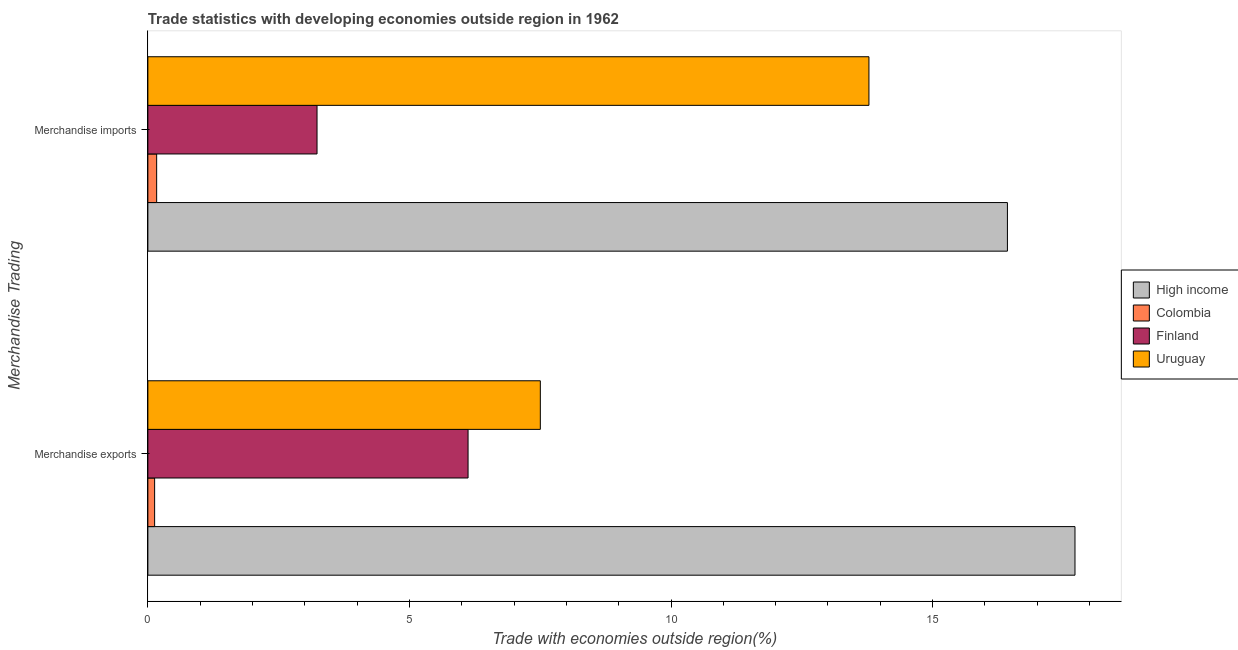How many different coloured bars are there?
Provide a short and direct response. 4. How many groups of bars are there?
Keep it short and to the point. 2. Are the number of bars on each tick of the Y-axis equal?
Make the answer very short. Yes. How many bars are there on the 1st tick from the top?
Give a very brief answer. 4. What is the merchandise imports in Uruguay?
Provide a succinct answer. 13.78. Across all countries, what is the maximum merchandise imports?
Make the answer very short. 16.43. Across all countries, what is the minimum merchandise exports?
Your answer should be compact. 0.13. In which country was the merchandise imports maximum?
Your answer should be compact. High income. What is the total merchandise exports in the graph?
Give a very brief answer. 31.47. What is the difference between the merchandise imports in Colombia and that in High income?
Your answer should be compact. -16.26. What is the difference between the merchandise imports in Colombia and the merchandise exports in High income?
Ensure brevity in your answer.  -17.55. What is the average merchandise imports per country?
Offer a very short reply. 8.4. What is the difference between the merchandise exports and merchandise imports in High income?
Ensure brevity in your answer.  1.29. What is the ratio of the merchandise imports in Finland to that in Uruguay?
Your response must be concise. 0.23. Is the merchandise imports in Finland less than that in Colombia?
Keep it short and to the point. No. In how many countries, is the merchandise exports greater than the average merchandise exports taken over all countries?
Offer a terse response. 1. How many countries are there in the graph?
Offer a terse response. 4. What is the difference between two consecutive major ticks on the X-axis?
Your response must be concise. 5. Are the values on the major ticks of X-axis written in scientific E-notation?
Keep it short and to the point. No. Where does the legend appear in the graph?
Your answer should be very brief. Center right. How many legend labels are there?
Ensure brevity in your answer.  4. How are the legend labels stacked?
Your answer should be very brief. Vertical. What is the title of the graph?
Provide a short and direct response. Trade statistics with developing economies outside region in 1962. What is the label or title of the X-axis?
Your response must be concise. Trade with economies outside region(%). What is the label or title of the Y-axis?
Your answer should be very brief. Merchandise Trading. What is the Trade with economies outside region(%) of High income in Merchandise exports?
Your answer should be compact. 17.72. What is the Trade with economies outside region(%) in Colombia in Merchandise exports?
Your answer should be compact. 0.13. What is the Trade with economies outside region(%) in Finland in Merchandise exports?
Provide a short and direct response. 6.12. What is the Trade with economies outside region(%) in Uruguay in Merchandise exports?
Give a very brief answer. 7.5. What is the Trade with economies outside region(%) in High income in Merchandise imports?
Provide a short and direct response. 16.43. What is the Trade with economies outside region(%) in Colombia in Merchandise imports?
Make the answer very short. 0.17. What is the Trade with economies outside region(%) of Finland in Merchandise imports?
Keep it short and to the point. 3.23. What is the Trade with economies outside region(%) in Uruguay in Merchandise imports?
Offer a terse response. 13.78. Across all Merchandise Trading, what is the maximum Trade with economies outside region(%) in High income?
Your response must be concise. 17.72. Across all Merchandise Trading, what is the maximum Trade with economies outside region(%) in Colombia?
Give a very brief answer. 0.17. Across all Merchandise Trading, what is the maximum Trade with economies outside region(%) of Finland?
Provide a short and direct response. 6.12. Across all Merchandise Trading, what is the maximum Trade with economies outside region(%) of Uruguay?
Make the answer very short. 13.78. Across all Merchandise Trading, what is the minimum Trade with economies outside region(%) of High income?
Your response must be concise. 16.43. Across all Merchandise Trading, what is the minimum Trade with economies outside region(%) in Colombia?
Offer a terse response. 0.13. Across all Merchandise Trading, what is the minimum Trade with economies outside region(%) in Finland?
Provide a short and direct response. 3.23. Across all Merchandise Trading, what is the minimum Trade with economies outside region(%) of Uruguay?
Provide a short and direct response. 7.5. What is the total Trade with economies outside region(%) of High income in the graph?
Make the answer very short. 34.15. What is the total Trade with economies outside region(%) of Colombia in the graph?
Make the answer very short. 0.3. What is the total Trade with economies outside region(%) of Finland in the graph?
Your answer should be compact. 9.35. What is the total Trade with economies outside region(%) in Uruguay in the graph?
Offer a very short reply. 21.28. What is the difference between the Trade with economies outside region(%) in High income in Merchandise exports and that in Merchandise imports?
Make the answer very short. 1.29. What is the difference between the Trade with economies outside region(%) of Colombia in Merchandise exports and that in Merchandise imports?
Provide a short and direct response. -0.04. What is the difference between the Trade with economies outside region(%) in Finland in Merchandise exports and that in Merchandise imports?
Offer a terse response. 2.89. What is the difference between the Trade with economies outside region(%) of Uruguay in Merchandise exports and that in Merchandise imports?
Provide a short and direct response. -6.28. What is the difference between the Trade with economies outside region(%) of High income in Merchandise exports and the Trade with economies outside region(%) of Colombia in Merchandise imports?
Provide a succinct answer. 17.55. What is the difference between the Trade with economies outside region(%) of High income in Merchandise exports and the Trade with economies outside region(%) of Finland in Merchandise imports?
Your answer should be very brief. 14.49. What is the difference between the Trade with economies outside region(%) of High income in Merchandise exports and the Trade with economies outside region(%) of Uruguay in Merchandise imports?
Make the answer very short. 3.94. What is the difference between the Trade with economies outside region(%) of Colombia in Merchandise exports and the Trade with economies outside region(%) of Finland in Merchandise imports?
Offer a very short reply. -3.1. What is the difference between the Trade with economies outside region(%) in Colombia in Merchandise exports and the Trade with economies outside region(%) in Uruguay in Merchandise imports?
Give a very brief answer. -13.65. What is the difference between the Trade with economies outside region(%) in Finland in Merchandise exports and the Trade with economies outside region(%) in Uruguay in Merchandise imports?
Offer a very short reply. -7.66. What is the average Trade with economies outside region(%) in High income per Merchandise Trading?
Offer a terse response. 17.08. What is the average Trade with economies outside region(%) in Colombia per Merchandise Trading?
Provide a short and direct response. 0.15. What is the average Trade with economies outside region(%) of Finland per Merchandise Trading?
Your answer should be very brief. 4.68. What is the average Trade with economies outside region(%) of Uruguay per Merchandise Trading?
Ensure brevity in your answer.  10.64. What is the difference between the Trade with economies outside region(%) in High income and Trade with economies outside region(%) in Colombia in Merchandise exports?
Ensure brevity in your answer.  17.59. What is the difference between the Trade with economies outside region(%) of High income and Trade with economies outside region(%) of Finland in Merchandise exports?
Offer a terse response. 11.6. What is the difference between the Trade with economies outside region(%) of High income and Trade with economies outside region(%) of Uruguay in Merchandise exports?
Make the answer very short. 10.22. What is the difference between the Trade with economies outside region(%) of Colombia and Trade with economies outside region(%) of Finland in Merchandise exports?
Ensure brevity in your answer.  -5.99. What is the difference between the Trade with economies outside region(%) in Colombia and Trade with economies outside region(%) in Uruguay in Merchandise exports?
Offer a terse response. -7.37. What is the difference between the Trade with economies outside region(%) of Finland and Trade with economies outside region(%) of Uruguay in Merchandise exports?
Keep it short and to the point. -1.38. What is the difference between the Trade with economies outside region(%) in High income and Trade with economies outside region(%) in Colombia in Merchandise imports?
Provide a succinct answer. 16.26. What is the difference between the Trade with economies outside region(%) of High income and Trade with economies outside region(%) of Finland in Merchandise imports?
Keep it short and to the point. 13.2. What is the difference between the Trade with economies outside region(%) in High income and Trade with economies outside region(%) in Uruguay in Merchandise imports?
Offer a terse response. 2.65. What is the difference between the Trade with economies outside region(%) of Colombia and Trade with economies outside region(%) of Finland in Merchandise imports?
Your answer should be very brief. -3.07. What is the difference between the Trade with economies outside region(%) of Colombia and Trade with economies outside region(%) of Uruguay in Merchandise imports?
Your answer should be very brief. -13.61. What is the difference between the Trade with economies outside region(%) in Finland and Trade with economies outside region(%) in Uruguay in Merchandise imports?
Your answer should be very brief. -10.55. What is the ratio of the Trade with economies outside region(%) in High income in Merchandise exports to that in Merchandise imports?
Give a very brief answer. 1.08. What is the ratio of the Trade with economies outside region(%) in Colombia in Merchandise exports to that in Merchandise imports?
Offer a very short reply. 0.77. What is the ratio of the Trade with economies outside region(%) of Finland in Merchandise exports to that in Merchandise imports?
Offer a very short reply. 1.89. What is the ratio of the Trade with economies outside region(%) of Uruguay in Merchandise exports to that in Merchandise imports?
Ensure brevity in your answer.  0.54. What is the difference between the highest and the second highest Trade with economies outside region(%) of High income?
Offer a terse response. 1.29. What is the difference between the highest and the second highest Trade with economies outside region(%) of Colombia?
Provide a short and direct response. 0.04. What is the difference between the highest and the second highest Trade with economies outside region(%) in Finland?
Provide a short and direct response. 2.89. What is the difference between the highest and the second highest Trade with economies outside region(%) in Uruguay?
Offer a terse response. 6.28. What is the difference between the highest and the lowest Trade with economies outside region(%) of High income?
Offer a very short reply. 1.29. What is the difference between the highest and the lowest Trade with economies outside region(%) in Colombia?
Offer a terse response. 0.04. What is the difference between the highest and the lowest Trade with economies outside region(%) in Finland?
Ensure brevity in your answer.  2.89. What is the difference between the highest and the lowest Trade with economies outside region(%) of Uruguay?
Give a very brief answer. 6.28. 